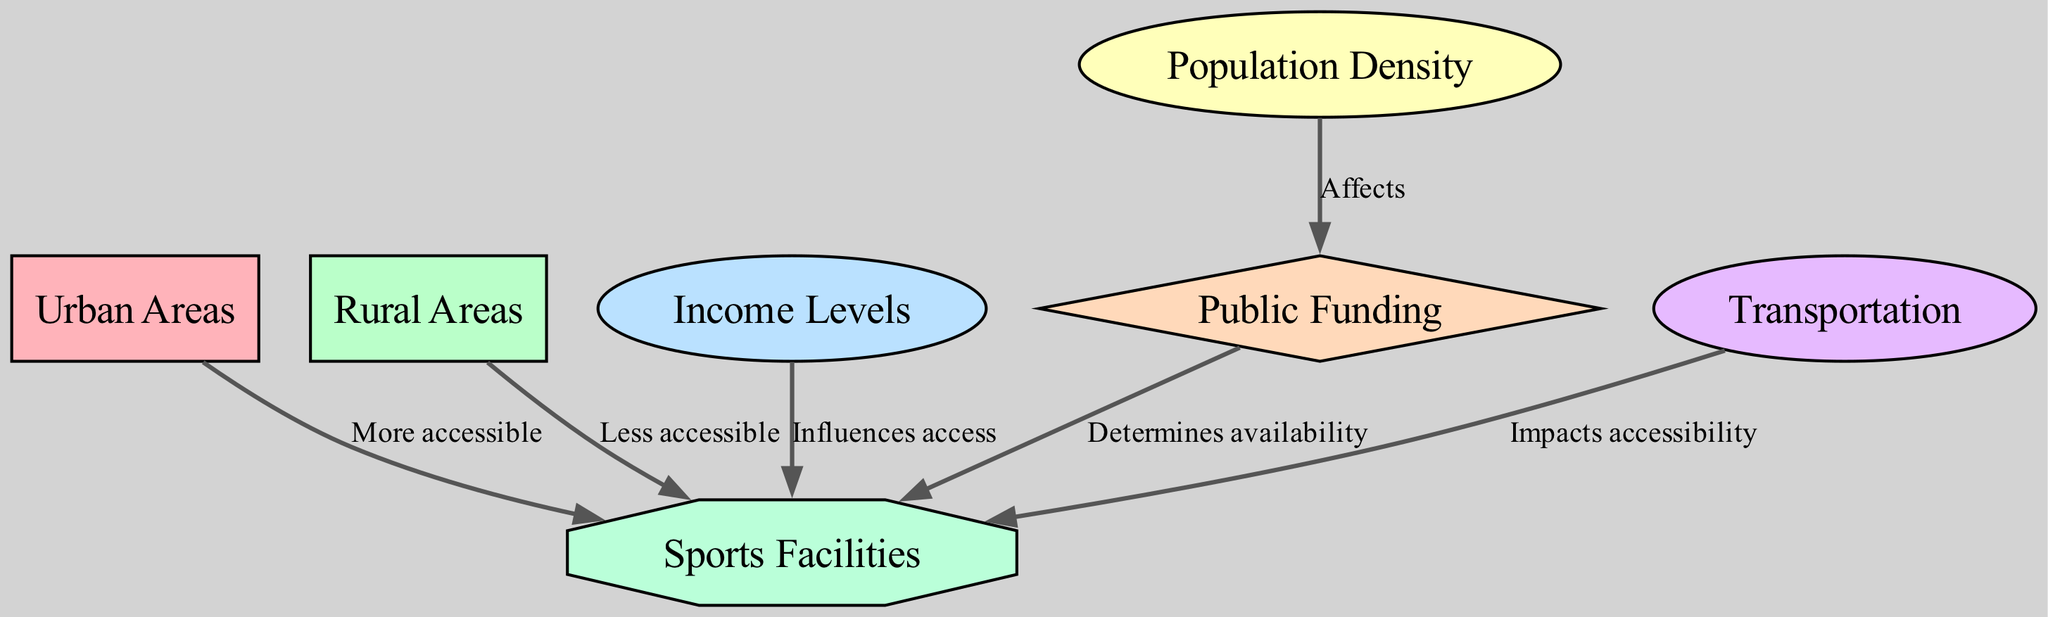What is the relationship between urban areas and sports facilities? The diagram shows an edge from "urban" to "facilities" labeled "More accessible". This indicates that sports facilities are generally more accessible in urban areas compared to rural areas.
Answer: More accessible How many nodes are present in the diagram? By counting the distinct nodes listed in the data, we identify seven nodes: urban, rural, income, population, funding, transport, and facilities.
Answer: 7 What influences access to sports facilities? The diagram shows an edge from "income" to "facilities" labeled "Influences access", indicating that income levels have a direct influence on access to sports facilities.
Answer: Income levels Which areas have less accessible sports facilities? The diagram clearly indicates that "rural" is directly connected to "facilities" with the label "Less accessible," signifying that rural areas have less access to sports facilities compared to urban areas.
Answer: Rural areas How does population density affect funding for sports facilities? According to the diagram, there is an edge from "population" to "funding" labeled "Affects." This shows that population density influences the amount of public funding available for sports facilities.
Answer: Affects What determines the availability of sports facilities in urban and rural areas? The diagram illustrates that "funding" has an edge leading to "facilities" labeled "Determines availability," which means that the availability of sports facilities is determined by the level of public funding.
Answer: Public funding What impact does transportation have on accessibility to sports facilities? The diagram presents an edge from "transport" to "facilities," labeled "Impacts accessibility." This shows that transportation plays a role in how accessible sports facilities are.
Answer: Impacts accessibility Which factor connects income levels and sports facilities? The diagram indicates a direct connection from the "income" node to the "facilities" node, labeled "Influences access," indicating that income levels can directly affect the access to sports facilities.
Answer: Influences access In which type of areas are sports facilities more accessible? The diagram has a direct line from "urban" to "facilities" labeled "More accessible," indicating that in urban areas, sports facilities are generally more accessible.
Answer: Urban areas 